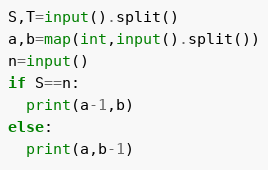<code> <loc_0><loc_0><loc_500><loc_500><_Python_>S,T=input().split()
a,b=map(int,input().split())
n=input()
if S==n:
  print(a-1,b)
else:
  print(a,b-1)</code> 